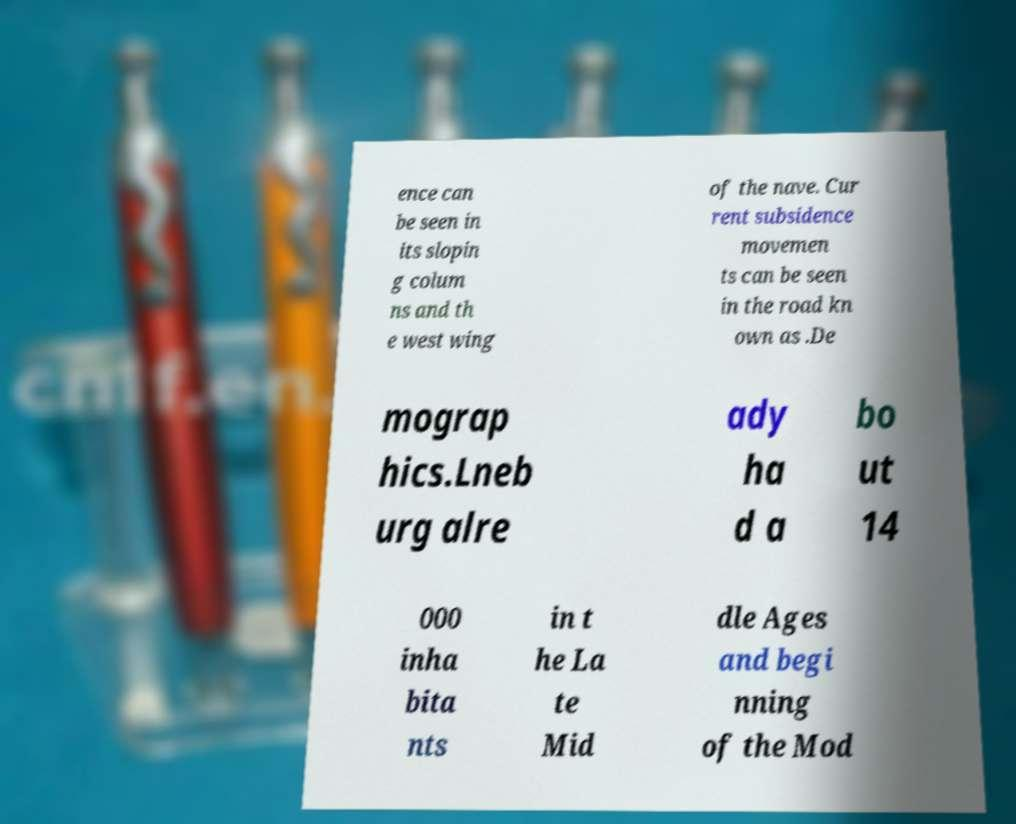Can you read and provide the text displayed in the image?This photo seems to have some interesting text. Can you extract and type it out for me? ence can be seen in its slopin g colum ns and th e west wing of the nave. Cur rent subsidence movemen ts can be seen in the road kn own as .De mograp hics.Lneb urg alre ady ha d a bo ut 14 000 inha bita nts in t he La te Mid dle Ages and begi nning of the Mod 